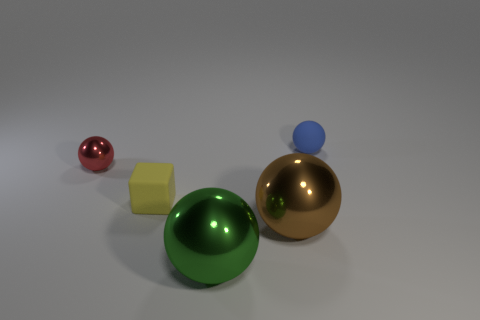Add 4 tiny purple objects. How many objects exist? 9 Subtract all spheres. How many objects are left? 1 Add 1 red shiny things. How many red shiny things are left? 2 Add 4 small metallic cylinders. How many small metallic cylinders exist? 4 Subtract 0 purple spheres. How many objects are left? 5 Subtract all big brown matte objects. Subtract all small things. How many objects are left? 2 